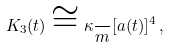Convert formula to latex. <formula><loc_0><loc_0><loc_500><loc_500>K _ { 3 } ( t ) \cong \kappa \frac { } { m } [ a ( t ) ] ^ { 4 } \, ,</formula> 